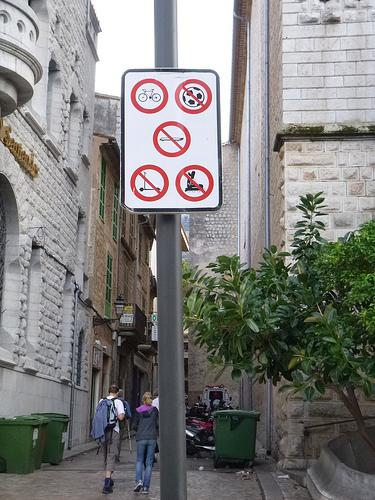Question: what color are the buildings?
Choices:
A. White and brown.
B. Black.
C. Blue.
D. Yellow.
Answer with the letter. Answer: A Question: what are the buildings made of?
Choices:
A. Wood.
B. Glass.
C. Metal.
D. Stone.
Answer with the letter. Answer: D 